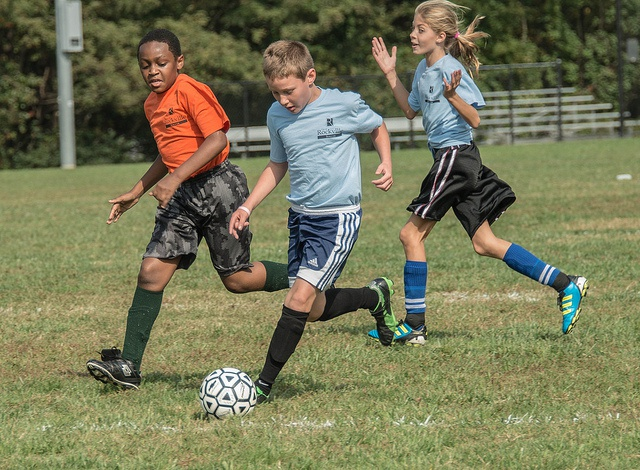Describe the objects in this image and their specific colors. I can see people in darkgreen, black, lightblue, gray, and darkgray tones, people in darkgreen, black, gray, and red tones, people in darkgreen, black, gray, and tan tones, and sports ball in darkgreen, ivory, darkgray, gray, and beige tones in this image. 